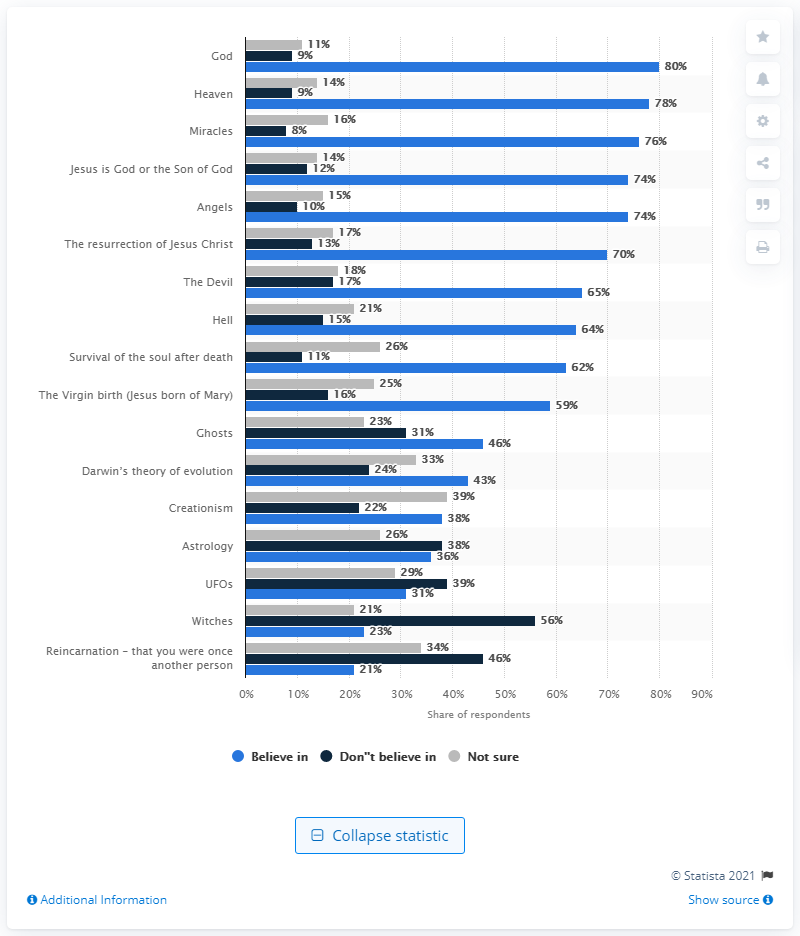Mention a couple of crucial points in this snapshot. According to a survey conducted among teenagers, 80% of them believed in God. 